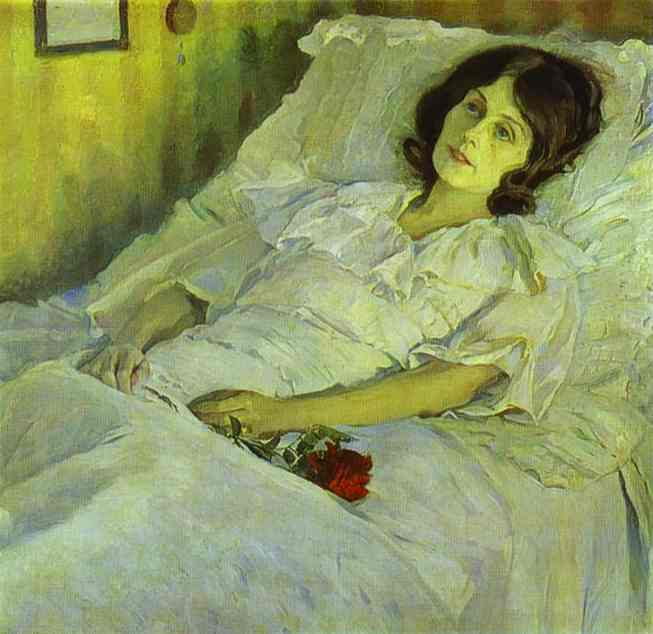Can you describe the main features of this image for me? The image presents an evocative oil painting featuring a young woman lying thoughtfully in a white bed. She holds a bouquet of vivid red flowers, suggesting a moment of deep personal reflection or a significant life event. The painting employs an impressionist style, with loose, expressive brushstrokes that capture the subtle interplay of light and shadow across her face and the bed. Soft, warm tones of yellow and green in the background contrast with the striking red of the flowers, creating a visually arresting composition. This artwork likely delves into themes of femininity, solitude, and perhaps introspection, typical of figurative art which aims to capture more than mere physical appearances by imbuing the subject with emotional depth. 